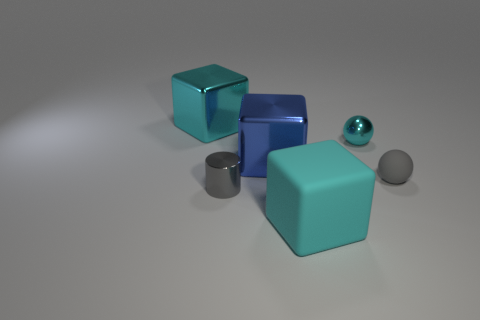What materials do the objects in the image seem to be made of? The objects in the image look like they are made of synthetic materials with reflective surfaces, resembling metals or polished plastics. Their shine and reflections suggest that they are smooth and possibly metallic, which is commonly used in 3D renderings to simulate real-world objects. 